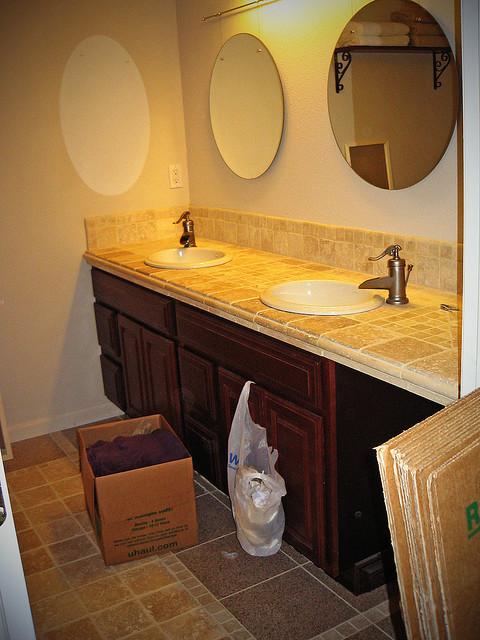What is in the box?
Answer briefly. Towels. Is this a kitchen?
Give a very brief answer. No. Is this room under construction?
Keep it brief. Yes. What room is shown?
Give a very brief answer. Bathroom. 